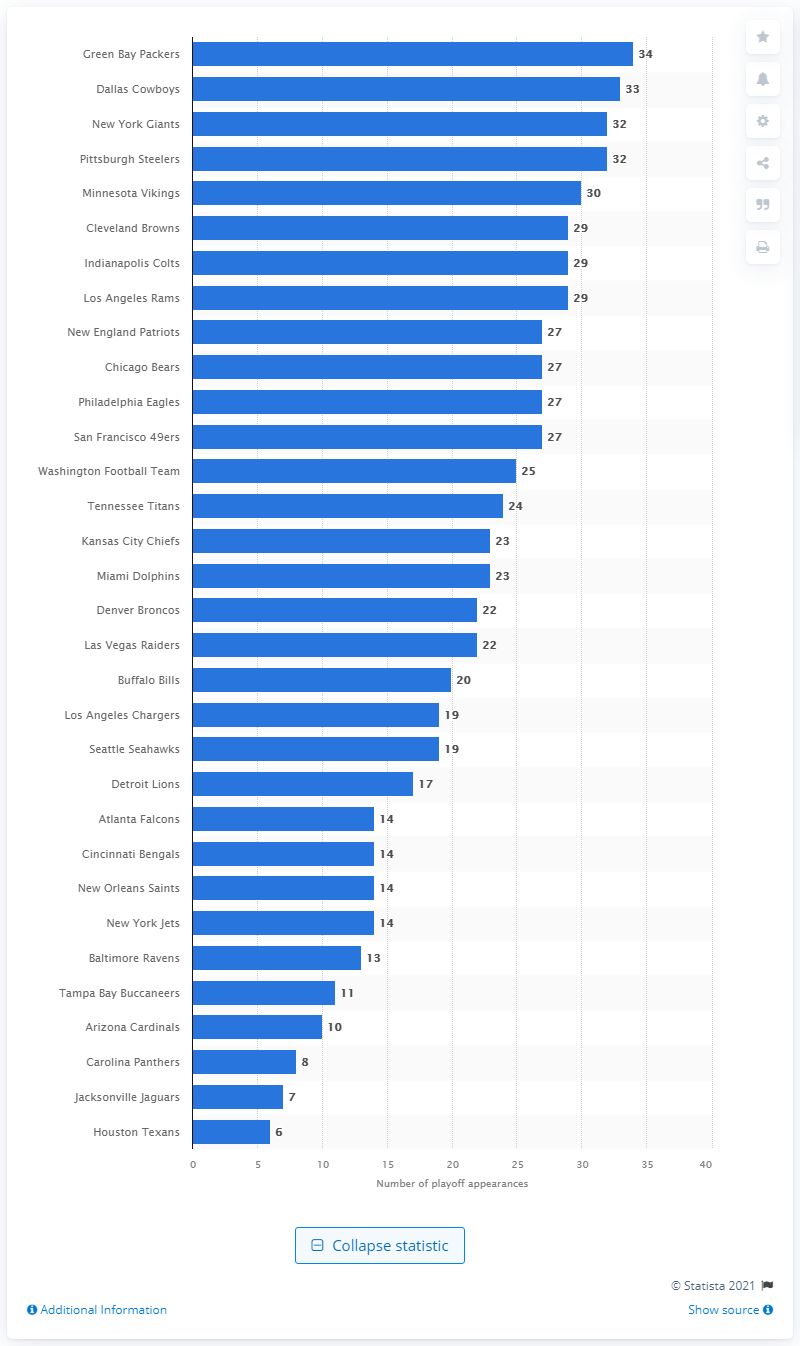Point out several critical features in this image. The New England Patriots have been far more successful since the beginning of the new millennium than any other team. The New England Patriots have made the playoffs 17 times. The Dallas Cowboys have made 34 playoff appearances, demonstrating their consistency and dominance in the NFL. The Dallas Cowboys have the most playoff appearances out of all the teams. 